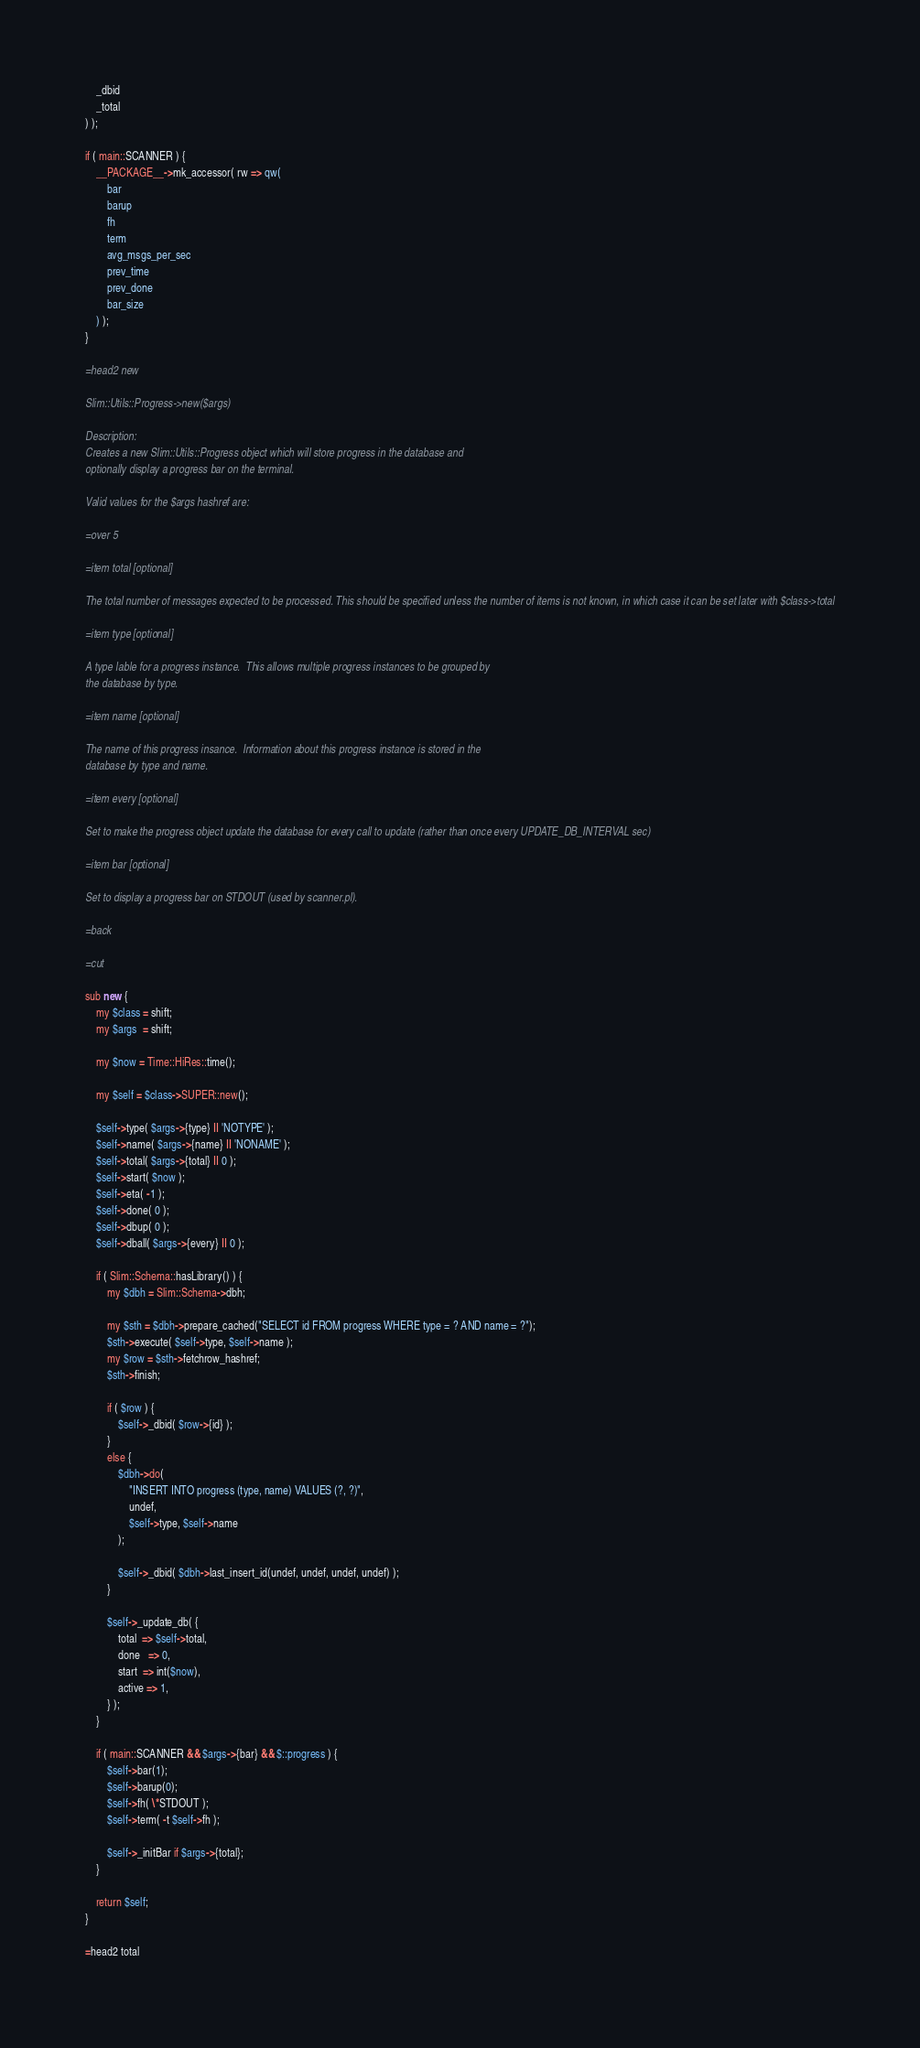<code> <loc_0><loc_0><loc_500><loc_500><_Perl_>	_dbid
	_total
) );

if ( main::SCANNER ) {
	__PACKAGE__->mk_accessor( rw => qw(
		bar
		barup
		fh
		term
		avg_msgs_per_sec
		prev_time
		prev_done
		bar_size
	) );
}

=head2 new

Slim::Utils::Progress->new($args)

Description:
Creates a new Slim::Utils::Progress object which will store progress in the database and
optionally display a progress bar on the terminal.

Valid values for the $args hashref are:

=over 5

=item total [optional]

The total number of messages expected to be processed. This should be specified unless the number of items is not known, in which case it can be set later with $class->total

=item type [optional]

A type lable for a progress instance.  This allows multiple progress instances to be grouped by
the database by type.

=item name [optional]

The name of this progress insance.  Information about this progress instance is stored in the
database by type and name.

=item every [optional]

Set to make the progress object update the database for every call to update (rather than once every UPDATE_DB_INTERVAL sec)

=item bar [optional]

Set to display a progress bar on STDOUT (used by scanner.pl).

=back

=cut

sub new {
	my $class = shift;
	my $args  = shift;
	
	my $now = Time::HiRes::time();
	
	my $self = $class->SUPER::new();
	
	$self->type( $args->{type} || 'NOTYPE' );
	$self->name( $args->{name} || 'NONAME' );
	$self->total( $args->{total} || 0 );
	$self->start( $now );
	$self->eta( -1 );
	$self->done( 0 );
	$self->dbup( 0 );
	$self->dball( $args->{every} || 0 );

	if ( Slim::Schema::hasLibrary() ) {
		my $dbh = Slim::Schema->dbh;
		
		my $sth = $dbh->prepare_cached("SELECT id FROM progress WHERE type = ? AND name = ?");
		$sth->execute( $self->type, $self->name );
		my $row = $sth->fetchrow_hashref;
		$sth->finish;
		
		if ( $row ) {
			$self->_dbid( $row->{id} );
		}
		else {
			$dbh->do(
				"INSERT INTO progress (type, name) VALUES (?, ?)",
				undef,
				$self->type, $self->name
			);
			
			$self->_dbid( $dbh->last_insert_id(undef, undef, undef, undef) );
		}
		
		$self->_update_db( {
			total  => $self->total,
			done   => 0,
			start  => int($now),
			active => 1,
		} );
	}
	
	if ( main::SCANNER && $args->{bar} && $::progress ) {
		$self->bar(1);
		$self->barup(0);
		$self->fh( \*STDOUT );
		$self->term( -t $self->fh );
		
		$self->_initBar if $args->{total};
	}

	return $self;
}

=head2 total
</code> 